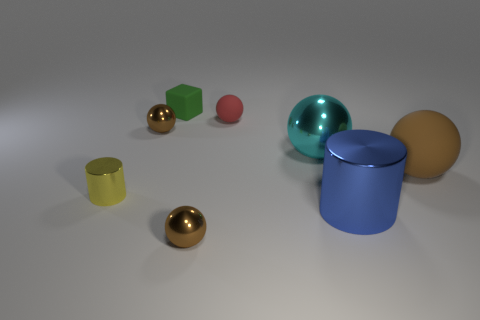Is there any other thing that is made of the same material as the green block?
Keep it short and to the point. Yes. What size is the blue cylinder?
Offer a very short reply. Large. There is a rubber object that is both on the left side of the blue shiny object and in front of the tiny rubber block; what color is it?
Keep it short and to the point. Red. Is the number of blue cylinders greater than the number of gray rubber blocks?
Keep it short and to the point. Yes. What number of objects are either big objects or shiny cylinders that are behind the blue shiny cylinder?
Offer a terse response. 4. Does the cyan object have the same size as the green rubber cube?
Keep it short and to the point. No. There is a matte block; are there any small yellow cylinders on the right side of it?
Your answer should be very brief. No. There is a rubber object that is in front of the green rubber object and to the left of the large metal ball; what is its size?
Provide a succinct answer. Small. How many objects are either big blue shiny cylinders or big brown objects?
Your response must be concise. 2. There is a cyan metal thing; is its size the same as the ball on the left side of the green matte block?
Your response must be concise. No. 